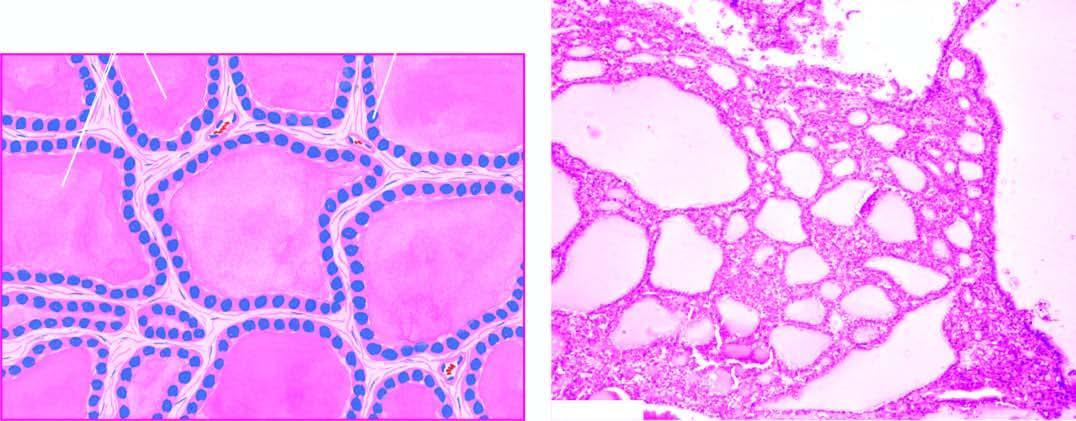does microscopy show large follicles distended by colloid and lined by flattened follicular epithelium?
Answer the question using a single word or phrase. Yes 